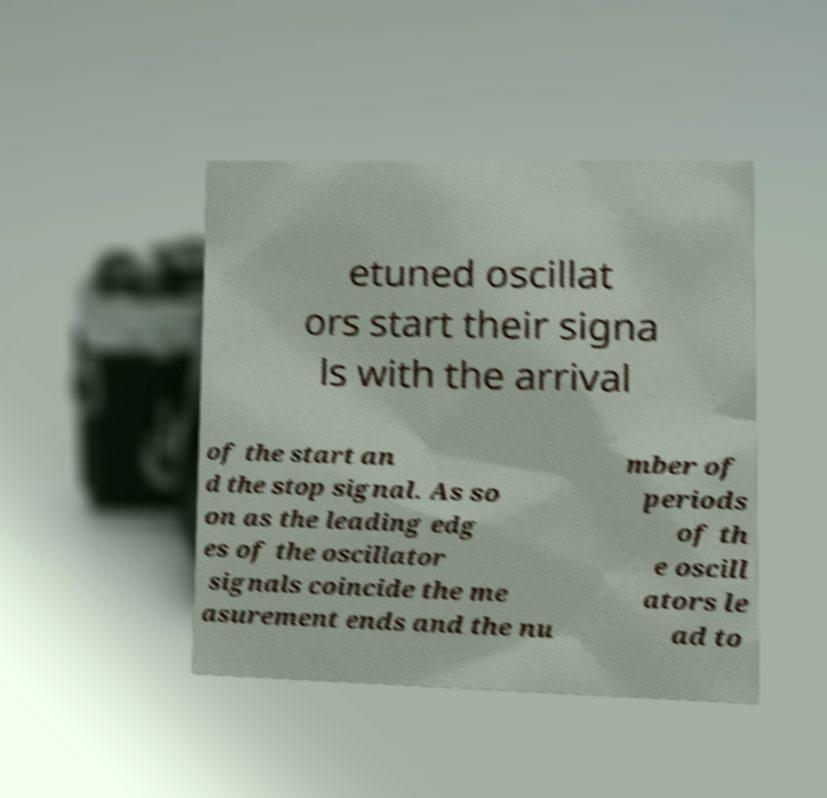Please read and relay the text visible in this image. What does it say? etuned oscillat ors start their signa ls with the arrival of the start an d the stop signal. As so on as the leading edg es of the oscillator signals coincide the me asurement ends and the nu mber of periods of th e oscill ators le ad to 